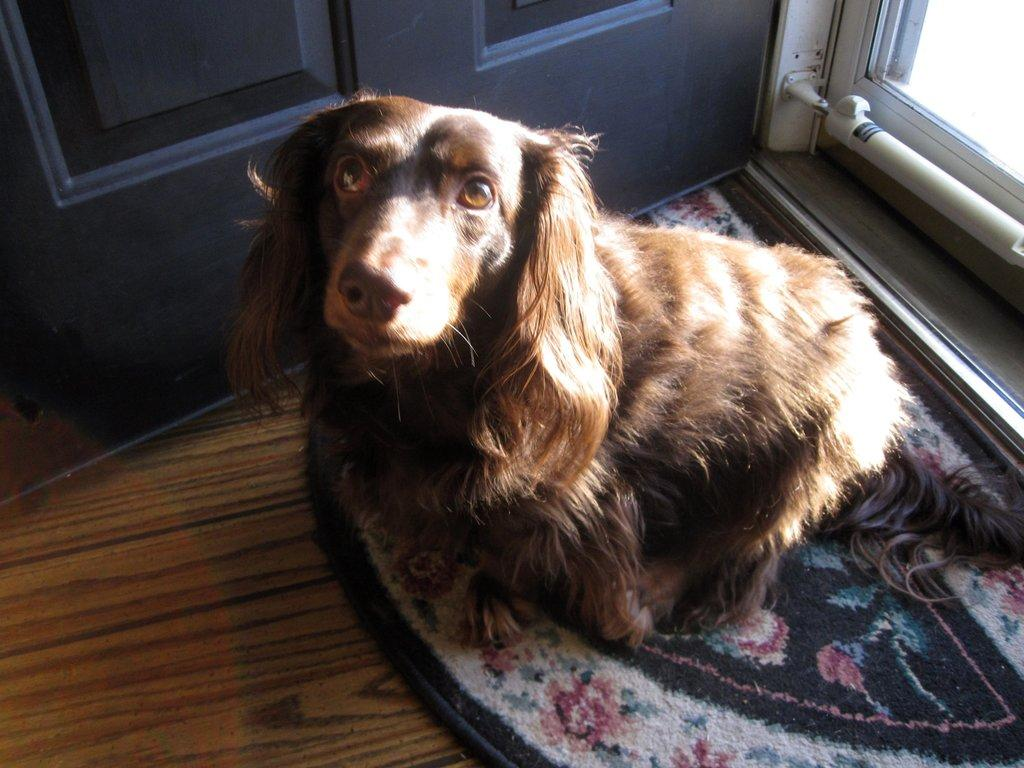What animal is present in the image? There is a dog in the image. What is the dog doing in the image? The dog is sitting on a doormat. What is the color of the dog in the image? The dog is brown in color. What is located on the left side of the image? There is a door on the left side of the image. What type of industry is depicted in the image? There is no industry depicted in the image; it features a dog sitting on a doormat. What type of loss is being experienced by the dog in the image? There is no indication of any loss being experienced by the dog in the image. 